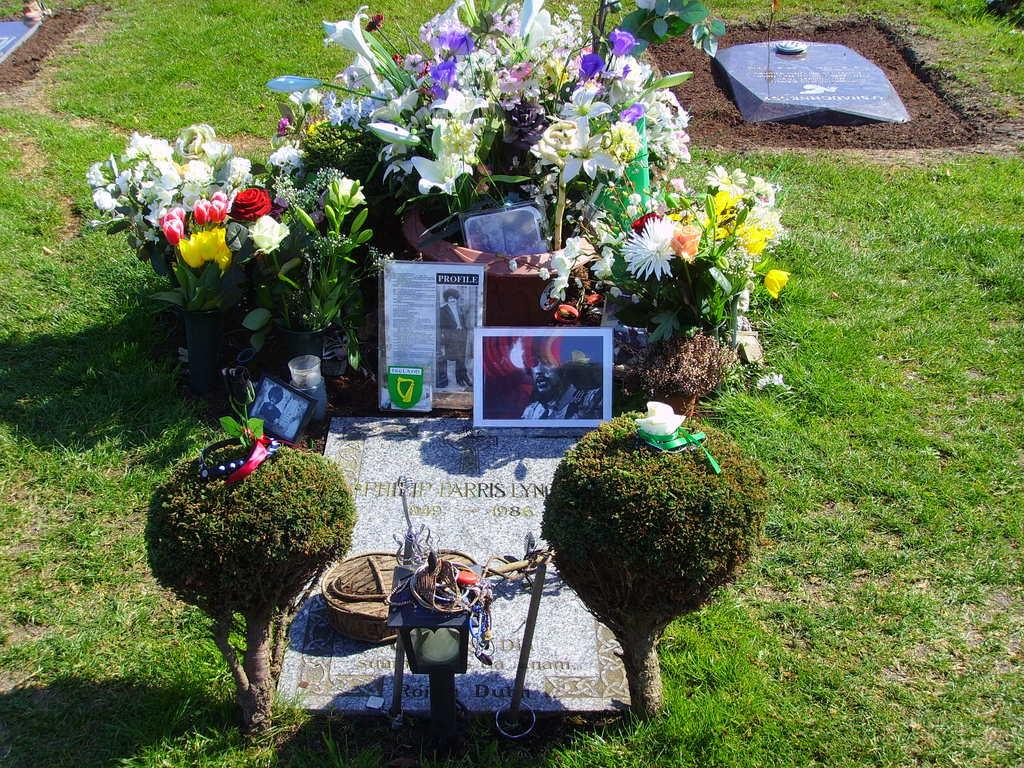What type of plants can be seen in the image? There are flowers in the image. What else can be seen in the image besides the flowers? There are photo frames in the image. Where are the flowers and photo frames located? They are placed on a person's grave. Are there any other graves visible in the image? Yes, there is another grave visible in the image. What is the ground surface like in the image? There is a grass lawn in the image. What is the riddle that the flowers are trying to solve in the image? There is no riddle present in the image; the flowers are simply decorative elements placed on a grave. 